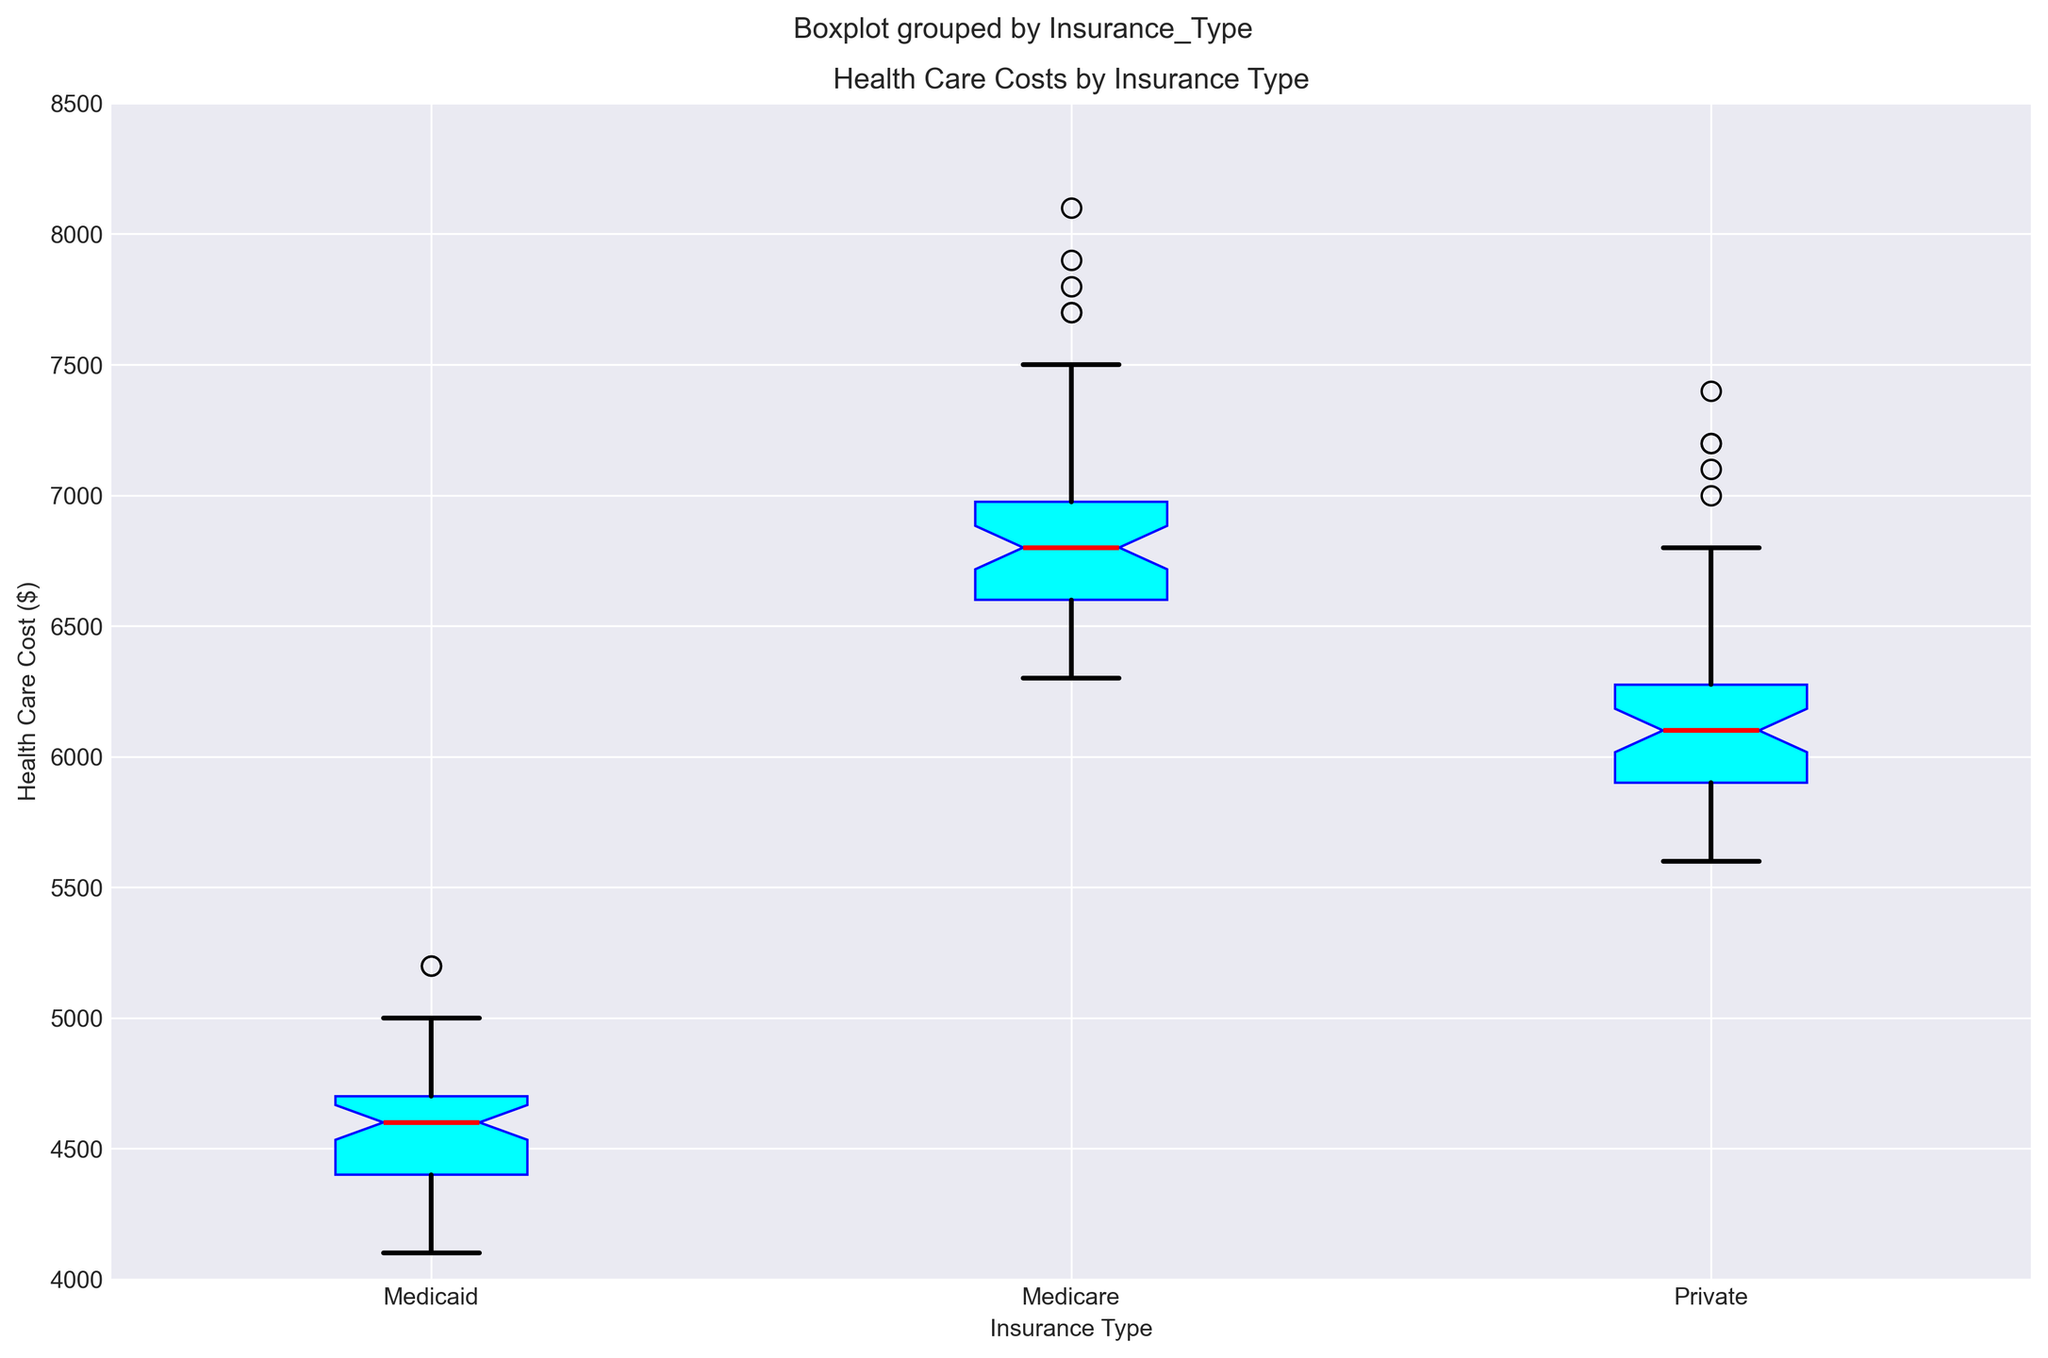What's the median health care cost for Private insurance? The median represents the middle value of a dataset. For the Private insurance category, visually locate the red line in the box plot which indicates the median.
Answer: 6100 What is the range of health care costs for Medicaid insurance? The range is calculated by subtracting the minimum value from the maximum value. Visually identify the top and bottom ends of the whiskers for the Medicaid insurance category to find these values.
Answer: 5200 - 4100 = 1100 Which insurance type has the highest median health care cost? Compare the median lines (red lines) in the boxes for each insurance type. The highest median is the one with the red line positioned the highest on the y-axis.
Answer: Medicare How do the spread (Interquartile Range, IQR) of health care costs compare between Private and Medicaid insurance? The IQR is the difference between the third quartile (top of the box) and the first quartile (bottom of the box). Visually compare the height of the boxes for Private and Medicaid insurance to determine which has a larger IQR.
Answer: Private has a larger IQR Are there any outliers in the Private insurance type? Outliers are typically represented by individual points outside the whiskers of the box plot. Look for any such points in the Private insurance section.
Answer: No Between Medicare and Medicaid insurance, which has a smaller spread? The spread is represented by the length of the box and whiskers. Measure the lengths visually for Medicare and Medicaid to determine which is smaller.
Answer: Medicaid Which insurance type shows the most consistent health care costs across states? Consistency can be inferred from the smallest spread (box and whiskers). Visually inspect which insurance type has the smallest overall spread.
Answer: Medicaid 